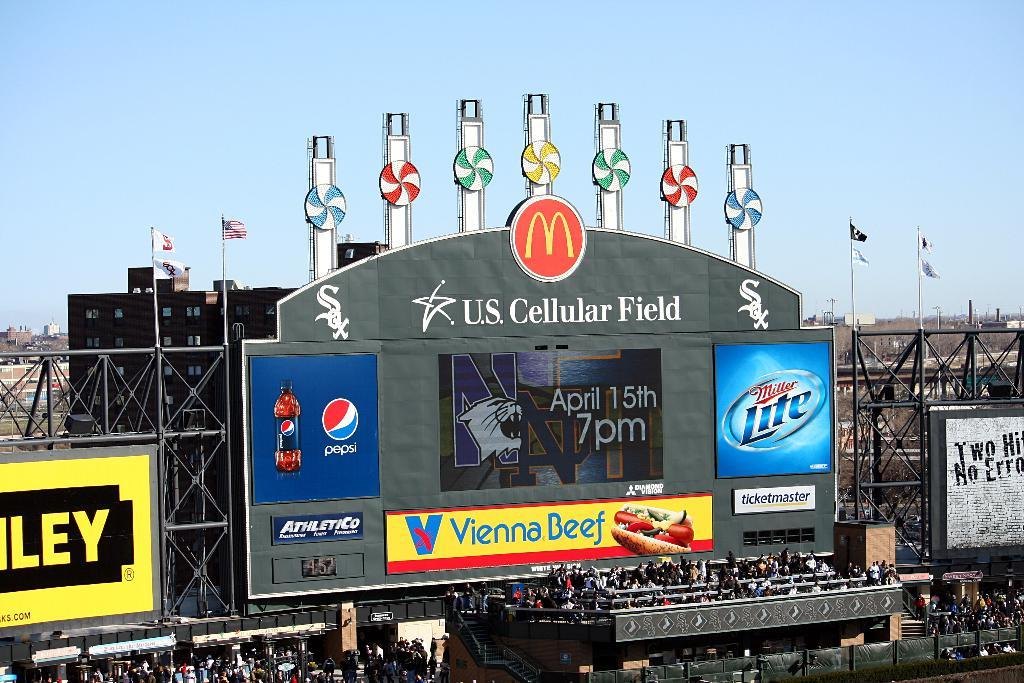<image>
Offer a succinct explanation of the picture presented. an outfield sign with a McDonald's advertisement on it 